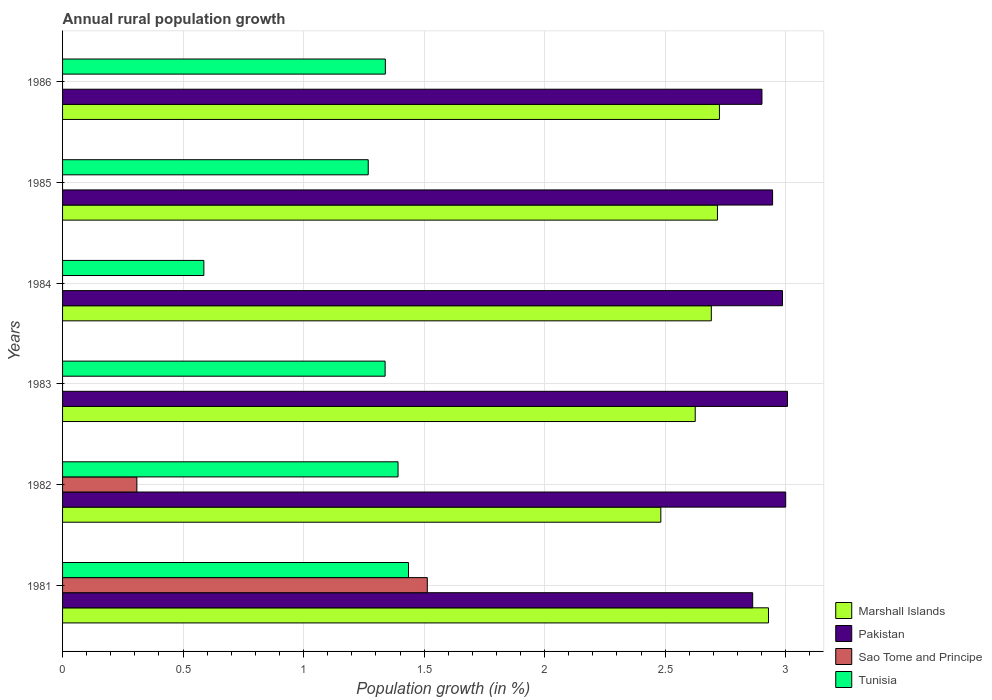Are the number of bars per tick equal to the number of legend labels?
Offer a terse response. No. How many bars are there on the 1st tick from the top?
Make the answer very short. 3. In how many cases, is the number of bars for a given year not equal to the number of legend labels?
Your response must be concise. 4. What is the percentage of rural population growth in Tunisia in 1983?
Keep it short and to the point. 1.34. Across all years, what is the maximum percentage of rural population growth in Pakistan?
Your answer should be very brief. 3.01. Across all years, what is the minimum percentage of rural population growth in Marshall Islands?
Ensure brevity in your answer.  2.48. In which year was the percentage of rural population growth in Tunisia maximum?
Offer a terse response. 1981. What is the total percentage of rural population growth in Marshall Islands in the graph?
Provide a short and direct response. 16.17. What is the difference between the percentage of rural population growth in Pakistan in 1983 and that in 1985?
Your answer should be compact. 0.06. What is the difference between the percentage of rural population growth in Tunisia in 1985 and the percentage of rural population growth in Marshall Islands in 1983?
Make the answer very short. -1.36. What is the average percentage of rural population growth in Pakistan per year?
Your response must be concise. 2.95. In the year 1985, what is the difference between the percentage of rural population growth in Pakistan and percentage of rural population growth in Tunisia?
Give a very brief answer. 1.68. What is the ratio of the percentage of rural population growth in Tunisia in 1981 to that in 1985?
Offer a terse response. 1.13. Is the percentage of rural population growth in Marshall Islands in 1981 less than that in 1985?
Offer a terse response. No. Is the difference between the percentage of rural population growth in Pakistan in 1982 and 1983 greater than the difference between the percentage of rural population growth in Tunisia in 1982 and 1983?
Give a very brief answer. No. What is the difference between the highest and the second highest percentage of rural population growth in Pakistan?
Offer a very short reply. 0.01. What is the difference between the highest and the lowest percentage of rural population growth in Marshall Islands?
Make the answer very short. 0.45. Is it the case that in every year, the sum of the percentage of rural population growth in Marshall Islands and percentage of rural population growth in Sao Tome and Principe is greater than the sum of percentage of rural population growth in Pakistan and percentage of rural population growth in Tunisia?
Make the answer very short. No. How many years are there in the graph?
Make the answer very short. 6. What is the difference between two consecutive major ticks on the X-axis?
Offer a terse response. 0.5. Are the values on the major ticks of X-axis written in scientific E-notation?
Your answer should be very brief. No. Does the graph contain grids?
Your response must be concise. Yes. Where does the legend appear in the graph?
Provide a succinct answer. Bottom right. What is the title of the graph?
Make the answer very short. Annual rural population growth. Does "Liechtenstein" appear as one of the legend labels in the graph?
Provide a succinct answer. No. What is the label or title of the X-axis?
Your answer should be very brief. Population growth (in %). What is the Population growth (in %) in Marshall Islands in 1981?
Keep it short and to the point. 2.93. What is the Population growth (in %) of Pakistan in 1981?
Your answer should be very brief. 2.86. What is the Population growth (in %) of Sao Tome and Principe in 1981?
Offer a terse response. 1.51. What is the Population growth (in %) in Tunisia in 1981?
Make the answer very short. 1.44. What is the Population growth (in %) in Marshall Islands in 1982?
Offer a terse response. 2.48. What is the Population growth (in %) of Pakistan in 1982?
Give a very brief answer. 3. What is the Population growth (in %) in Sao Tome and Principe in 1982?
Your response must be concise. 0.31. What is the Population growth (in %) in Tunisia in 1982?
Offer a terse response. 1.39. What is the Population growth (in %) of Marshall Islands in 1983?
Offer a very short reply. 2.62. What is the Population growth (in %) of Pakistan in 1983?
Provide a succinct answer. 3.01. What is the Population growth (in %) in Sao Tome and Principe in 1983?
Provide a succinct answer. 0. What is the Population growth (in %) in Tunisia in 1983?
Keep it short and to the point. 1.34. What is the Population growth (in %) in Marshall Islands in 1984?
Offer a very short reply. 2.69. What is the Population growth (in %) in Pakistan in 1984?
Ensure brevity in your answer.  2.99. What is the Population growth (in %) of Tunisia in 1984?
Make the answer very short. 0.59. What is the Population growth (in %) of Marshall Islands in 1985?
Your answer should be compact. 2.72. What is the Population growth (in %) of Pakistan in 1985?
Make the answer very short. 2.95. What is the Population growth (in %) in Tunisia in 1985?
Make the answer very short. 1.27. What is the Population growth (in %) in Marshall Islands in 1986?
Ensure brevity in your answer.  2.73. What is the Population growth (in %) of Pakistan in 1986?
Provide a short and direct response. 2.9. What is the Population growth (in %) in Tunisia in 1986?
Your answer should be compact. 1.34. Across all years, what is the maximum Population growth (in %) of Marshall Islands?
Ensure brevity in your answer.  2.93. Across all years, what is the maximum Population growth (in %) of Pakistan?
Make the answer very short. 3.01. Across all years, what is the maximum Population growth (in %) of Sao Tome and Principe?
Make the answer very short. 1.51. Across all years, what is the maximum Population growth (in %) in Tunisia?
Provide a succinct answer. 1.44. Across all years, what is the minimum Population growth (in %) in Marshall Islands?
Your response must be concise. 2.48. Across all years, what is the minimum Population growth (in %) in Pakistan?
Offer a very short reply. 2.86. Across all years, what is the minimum Population growth (in %) of Tunisia?
Give a very brief answer. 0.59. What is the total Population growth (in %) in Marshall Islands in the graph?
Your answer should be compact. 16.17. What is the total Population growth (in %) of Pakistan in the graph?
Your answer should be very brief. 17.7. What is the total Population growth (in %) of Sao Tome and Principe in the graph?
Offer a terse response. 1.82. What is the total Population growth (in %) in Tunisia in the graph?
Provide a succinct answer. 7.36. What is the difference between the Population growth (in %) of Marshall Islands in 1981 and that in 1982?
Your answer should be very brief. 0.45. What is the difference between the Population growth (in %) in Pakistan in 1981 and that in 1982?
Provide a short and direct response. -0.14. What is the difference between the Population growth (in %) of Sao Tome and Principe in 1981 and that in 1982?
Make the answer very short. 1.2. What is the difference between the Population growth (in %) of Tunisia in 1981 and that in 1982?
Give a very brief answer. 0.04. What is the difference between the Population growth (in %) of Marshall Islands in 1981 and that in 1983?
Ensure brevity in your answer.  0.3. What is the difference between the Population growth (in %) of Pakistan in 1981 and that in 1983?
Your answer should be very brief. -0.14. What is the difference between the Population growth (in %) in Tunisia in 1981 and that in 1983?
Your response must be concise. 0.1. What is the difference between the Population growth (in %) of Marshall Islands in 1981 and that in 1984?
Ensure brevity in your answer.  0.24. What is the difference between the Population growth (in %) in Pakistan in 1981 and that in 1984?
Ensure brevity in your answer.  -0.12. What is the difference between the Population growth (in %) in Tunisia in 1981 and that in 1984?
Offer a terse response. 0.85. What is the difference between the Population growth (in %) of Marshall Islands in 1981 and that in 1985?
Ensure brevity in your answer.  0.21. What is the difference between the Population growth (in %) in Pakistan in 1981 and that in 1985?
Your response must be concise. -0.08. What is the difference between the Population growth (in %) in Tunisia in 1981 and that in 1985?
Provide a short and direct response. 0.17. What is the difference between the Population growth (in %) in Marshall Islands in 1981 and that in 1986?
Provide a succinct answer. 0.2. What is the difference between the Population growth (in %) in Pakistan in 1981 and that in 1986?
Offer a very short reply. -0.04. What is the difference between the Population growth (in %) in Tunisia in 1981 and that in 1986?
Ensure brevity in your answer.  0.1. What is the difference between the Population growth (in %) of Marshall Islands in 1982 and that in 1983?
Keep it short and to the point. -0.14. What is the difference between the Population growth (in %) in Pakistan in 1982 and that in 1983?
Provide a succinct answer. -0.01. What is the difference between the Population growth (in %) in Tunisia in 1982 and that in 1983?
Your answer should be compact. 0.05. What is the difference between the Population growth (in %) in Marshall Islands in 1982 and that in 1984?
Provide a succinct answer. -0.21. What is the difference between the Population growth (in %) of Pakistan in 1982 and that in 1984?
Provide a succinct answer. 0.01. What is the difference between the Population growth (in %) of Tunisia in 1982 and that in 1984?
Give a very brief answer. 0.81. What is the difference between the Population growth (in %) in Marshall Islands in 1982 and that in 1985?
Provide a succinct answer. -0.23. What is the difference between the Population growth (in %) of Pakistan in 1982 and that in 1985?
Offer a terse response. 0.05. What is the difference between the Population growth (in %) of Tunisia in 1982 and that in 1985?
Provide a succinct answer. 0.12. What is the difference between the Population growth (in %) in Marshall Islands in 1982 and that in 1986?
Offer a very short reply. -0.24. What is the difference between the Population growth (in %) in Pakistan in 1982 and that in 1986?
Your answer should be compact. 0.1. What is the difference between the Population growth (in %) of Tunisia in 1982 and that in 1986?
Your response must be concise. 0.05. What is the difference between the Population growth (in %) of Marshall Islands in 1983 and that in 1984?
Offer a terse response. -0.07. What is the difference between the Population growth (in %) of Pakistan in 1983 and that in 1984?
Give a very brief answer. 0.02. What is the difference between the Population growth (in %) of Tunisia in 1983 and that in 1984?
Your answer should be compact. 0.75. What is the difference between the Population growth (in %) in Marshall Islands in 1983 and that in 1985?
Keep it short and to the point. -0.09. What is the difference between the Population growth (in %) in Pakistan in 1983 and that in 1985?
Give a very brief answer. 0.06. What is the difference between the Population growth (in %) in Tunisia in 1983 and that in 1985?
Offer a very short reply. 0.07. What is the difference between the Population growth (in %) in Marshall Islands in 1983 and that in 1986?
Provide a short and direct response. -0.1. What is the difference between the Population growth (in %) of Pakistan in 1983 and that in 1986?
Your answer should be very brief. 0.11. What is the difference between the Population growth (in %) in Tunisia in 1983 and that in 1986?
Give a very brief answer. -0. What is the difference between the Population growth (in %) of Marshall Islands in 1984 and that in 1985?
Ensure brevity in your answer.  -0.03. What is the difference between the Population growth (in %) of Pakistan in 1984 and that in 1985?
Your answer should be very brief. 0.04. What is the difference between the Population growth (in %) of Tunisia in 1984 and that in 1985?
Ensure brevity in your answer.  -0.68. What is the difference between the Population growth (in %) of Marshall Islands in 1984 and that in 1986?
Ensure brevity in your answer.  -0.03. What is the difference between the Population growth (in %) of Pakistan in 1984 and that in 1986?
Your answer should be very brief. 0.09. What is the difference between the Population growth (in %) of Tunisia in 1984 and that in 1986?
Make the answer very short. -0.75. What is the difference between the Population growth (in %) in Marshall Islands in 1985 and that in 1986?
Your response must be concise. -0.01. What is the difference between the Population growth (in %) of Pakistan in 1985 and that in 1986?
Provide a short and direct response. 0.04. What is the difference between the Population growth (in %) in Tunisia in 1985 and that in 1986?
Your answer should be compact. -0.07. What is the difference between the Population growth (in %) in Marshall Islands in 1981 and the Population growth (in %) in Pakistan in 1982?
Ensure brevity in your answer.  -0.07. What is the difference between the Population growth (in %) of Marshall Islands in 1981 and the Population growth (in %) of Sao Tome and Principe in 1982?
Your response must be concise. 2.62. What is the difference between the Population growth (in %) in Marshall Islands in 1981 and the Population growth (in %) in Tunisia in 1982?
Your answer should be compact. 1.54. What is the difference between the Population growth (in %) in Pakistan in 1981 and the Population growth (in %) in Sao Tome and Principe in 1982?
Provide a short and direct response. 2.55. What is the difference between the Population growth (in %) of Pakistan in 1981 and the Population growth (in %) of Tunisia in 1982?
Your response must be concise. 1.47. What is the difference between the Population growth (in %) of Sao Tome and Principe in 1981 and the Population growth (in %) of Tunisia in 1982?
Keep it short and to the point. 0.12. What is the difference between the Population growth (in %) of Marshall Islands in 1981 and the Population growth (in %) of Pakistan in 1983?
Your answer should be very brief. -0.08. What is the difference between the Population growth (in %) in Marshall Islands in 1981 and the Population growth (in %) in Tunisia in 1983?
Provide a succinct answer. 1.59. What is the difference between the Population growth (in %) in Pakistan in 1981 and the Population growth (in %) in Tunisia in 1983?
Ensure brevity in your answer.  1.52. What is the difference between the Population growth (in %) of Sao Tome and Principe in 1981 and the Population growth (in %) of Tunisia in 1983?
Provide a short and direct response. 0.18. What is the difference between the Population growth (in %) in Marshall Islands in 1981 and the Population growth (in %) in Pakistan in 1984?
Provide a short and direct response. -0.06. What is the difference between the Population growth (in %) of Marshall Islands in 1981 and the Population growth (in %) of Tunisia in 1984?
Ensure brevity in your answer.  2.34. What is the difference between the Population growth (in %) in Pakistan in 1981 and the Population growth (in %) in Tunisia in 1984?
Offer a terse response. 2.28. What is the difference between the Population growth (in %) of Sao Tome and Principe in 1981 and the Population growth (in %) of Tunisia in 1984?
Offer a terse response. 0.93. What is the difference between the Population growth (in %) of Marshall Islands in 1981 and the Population growth (in %) of Pakistan in 1985?
Make the answer very short. -0.02. What is the difference between the Population growth (in %) of Marshall Islands in 1981 and the Population growth (in %) of Tunisia in 1985?
Offer a terse response. 1.66. What is the difference between the Population growth (in %) of Pakistan in 1981 and the Population growth (in %) of Tunisia in 1985?
Keep it short and to the point. 1.59. What is the difference between the Population growth (in %) of Sao Tome and Principe in 1981 and the Population growth (in %) of Tunisia in 1985?
Your answer should be very brief. 0.25. What is the difference between the Population growth (in %) of Marshall Islands in 1981 and the Population growth (in %) of Pakistan in 1986?
Offer a very short reply. 0.03. What is the difference between the Population growth (in %) of Marshall Islands in 1981 and the Population growth (in %) of Tunisia in 1986?
Your answer should be very brief. 1.59. What is the difference between the Population growth (in %) in Pakistan in 1981 and the Population growth (in %) in Tunisia in 1986?
Offer a terse response. 1.52. What is the difference between the Population growth (in %) in Sao Tome and Principe in 1981 and the Population growth (in %) in Tunisia in 1986?
Ensure brevity in your answer.  0.17. What is the difference between the Population growth (in %) in Marshall Islands in 1982 and the Population growth (in %) in Pakistan in 1983?
Offer a very short reply. -0.53. What is the difference between the Population growth (in %) of Marshall Islands in 1982 and the Population growth (in %) of Tunisia in 1983?
Ensure brevity in your answer.  1.14. What is the difference between the Population growth (in %) in Pakistan in 1982 and the Population growth (in %) in Tunisia in 1983?
Provide a succinct answer. 1.66. What is the difference between the Population growth (in %) in Sao Tome and Principe in 1982 and the Population growth (in %) in Tunisia in 1983?
Ensure brevity in your answer.  -1.03. What is the difference between the Population growth (in %) of Marshall Islands in 1982 and the Population growth (in %) of Pakistan in 1984?
Make the answer very short. -0.5. What is the difference between the Population growth (in %) of Marshall Islands in 1982 and the Population growth (in %) of Tunisia in 1984?
Make the answer very short. 1.9. What is the difference between the Population growth (in %) in Pakistan in 1982 and the Population growth (in %) in Tunisia in 1984?
Offer a very short reply. 2.41. What is the difference between the Population growth (in %) of Sao Tome and Principe in 1982 and the Population growth (in %) of Tunisia in 1984?
Provide a succinct answer. -0.28. What is the difference between the Population growth (in %) of Marshall Islands in 1982 and the Population growth (in %) of Pakistan in 1985?
Ensure brevity in your answer.  -0.46. What is the difference between the Population growth (in %) in Marshall Islands in 1982 and the Population growth (in %) in Tunisia in 1985?
Your answer should be compact. 1.21. What is the difference between the Population growth (in %) of Pakistan in 1982 and the Population growth (in %) of Tunisia in 1985?
Provide a succinct answer. 1.73. What is the difference between the Population growth (in %) in Sao Tome and Principe in 1982 and the Population growth (in %) in Tunisia in 1985?
Offer a terse response. -0.96. What is the difference between the Population growth (in %) in Marshall Islands in 1982 and the Population growth (in %) in Pakistan in 1986?
Provide a short and direct response. -0.42. What is the difference between the Population growth (in %) in Marshall Islands in 1982 and the Population growth (in %) in Tunisia in 1986?
Make the answer very short. 1.14. What is the difference between the Population growth (in %) of Pakistan in 1982 and the Population growth (in %) of Tunisia in 1986?
Ensure brevity in your answer.  1.66. What is the difference between the Population growth (in %) in Sao Tome and Principe in 1982 and the Population growth (in %) in Tunisia in 1986?
Provide a short and direct response. -1.03. What is the difference between the Population growth (in %) in Marshall Islands in 1983 and the Population growth (in %) in Pakistan in 1984?
Your answer should be very brief. -0.36. What is the difference between the Population growth (in %) in Marshall Islands in 1983 and the Population growth (in %) in Tunisia in 1984?
Your answer should be very brief. 2.04. What is the difference between the Population growth (in %) of Pakistan in 1983 and the Population growth (in %) of Tunisia in 1984?
Your answer should be compact. 2.42. What is the difference between the Population growth (in %) of Marshall Islands in 1983 and the Population growth (in %) of Pakistan in 1985?
Give a very brief answer. -0.32. What is the difference between the Population growth (in %) in Marshall Islands in 1983 and the Population growth (in %) in Tunisia in 1985?
Give a very brief answer. 1.36. What is the difference between the Population growth (in %) of Pakistan in 1983 and the Population growth (in %) of Tunisia in 1985?
Make the answer very short. 1.74. What is the difference between the Population growth (in %) in Marshall Islands in 1983 and the Population growth (in %) in Pakistan in 1986?
Your answer should be very brief. -0.28. What is the difference between the Population growth (in %) in Marshall Islands in 1983 and the Population growth (in %) in Tunisia in 1986?
Offer a terse response. 1.29. What is the difference between the Population growth (in %) of Pakistan in 1983 and the Population growth (in %) of Tunisia in 1986?
Your answer should be very brief. 1.67. What is the difference between the Population growth (in %) in Marshall Islands in 1984 and the Population growth (in %) in Pakistan in 1985?
Provide a short and direct response. -0.25. What is the difference between the Population growth (in %) in Marshall Islands in 1984 and the Population growth (in %) in Tunisia in 1985?
Provide a short and direct response. 1.42. What is the difference between the Population growth (in %) in Pakistan in 1984 and the Population growth (in %) in Tunisia in 1985?
Keep it short and to the point. 1.72. What is the difference between the Population growth (in %) of Marshall Islands in 1984 and the Population growth (in %) of Pakistan in 1986?
Your response must be concise. -0.21. What is the difference between the Population growth (in %) of Marshall Islands in 1984 and the Population growth (in %) of Tunisia in 1986?
Offer a very short reply. 1.35. What is the difference between the Population growth (in %) of Pakistan in 1984 and the Population growth (in %) of Tunisia in 1986?
Provide a succinct answer. 1.65. What is the difference between the Population growth (in %) in Marshall Islands in 1985 and the Population growth (in %) in Pakistan in 1986?
Offer a very short reply. -0.18. What is the difference between the Population growth (in %) in Marshall Islands in 1985 and the Population growth (in %) in Tunisia in 1986?
Provide a succinct answer. 1.38. What is the difference between the Population growth (in %) in Pakistan in 1985 and the Population growth (in %) in Tunisia in 1986?
Make the answer very short. 1.61. What is the average Population growth (in %) of Marshall Islands per year?
Give a very brief answer. 2.69. What is the average Population growth (in %) in Pakistan per year?
Your response must be concise. 2.95. What is the average Population growth (in %) of Sao Tome and Principe per year?
Offer a very short reply. 0.3. What is the average Population growth (in %) of Tunisia per year?
Offer a terse response. 1.23. In the year 1981, what is the difference between the Population growth (in %) in Marshall Islands and Population growth (in %) in Pakistan?
Ensure brevity in your answer.  0.07. In the year 1981, what is the difference between the Population growth (in %) of Marshall Islands and Population growth (in %) of Sao Tome and Principe?
Make the answer very short. 1.42. In the year 1981, what is the difference between the Population growth (in %) of Marshall Islands and Population growth (in %) of Tunisia?
Offer a very short reply. 1.49. In the year 1981, what is the difference between the Population growth (in %) in Pakistan and Population growth (in %) in Sao Tome and Principe?
Give a very brief answer. 1.35. In the year 1981, what is the difference between the Population growth (in %) in Pakistan and Population growth (in %) in Tunisia?
Offer a terse response. 1.43. In the year 1981, what is the difference between the Population growth (in %) of Sao Tome and Principe and Population growth (in %) of Tunisia?
Provide a short and direct response. 0.08. In the year 1982, what is the difference between the Population growth (in %) in Marshall Islands and Population growth (in %) in Pakistan?
Provide a short and direct response. -0.52. In the year 1982, what is the difference between the Population growth (in %) in Marshall Islands and Population growth (in %) in Sao Tome and Principe?
Offer a very short reply. 2.17. In the year 1982, what is the difference between the Population growth (in %) of Marshall Islands and Population growth (in %) of Tunisia?
Provide a succinct answer. 1.09. In the year 1982, what is the difference between the Population growth (in %) in Pakistan and Population growth (in %) in Sao Tome and Principe?
Provide a succinct answer. 2.69. In the year 1982, what is the difference between the Population growth (in %) of Pakistan and Population growth (in %) of Tunisia?
Your answer should be very brief. 1.61. In the year 1982, what is the difference between the Population growth (in %) of Sao Tome and Principe and Population growth (in %) of Tunisia?
Offer a terse response. -1.08. In the year 1983, what is the difference between the Population growth (in %) of Marshall Islands and Population growth (in %) of Pakistan?
Provide a short and direct response. -0.38. In the year 1983, what is the difference between the Population growth (in %) in Marshall Islands and Population growth (in %) in Tunisia?
Provide a succinct answer. 1.29. In the year 1983, what is the difference between the Population growth (in %) of Pakistan and Population growth (in %) of Tunisia?
Keep it short and to the point. 1.67. In the year 1984, what is the difference between the Population growth (in %) in Marshall Islands and Population growth (in %) in Pakistan?
Your answer should be compact. -0.3. In the year 1984, what is the difference between the Population growth (in %) in Marshall Islands and Population growth (in %) in Tunisia?
Ensure brevity in your answer.  2.11. In the year 1984, what is the difference between the Population growth (in %) of Pakistan and Population growth (in %) of Tunisia?
Give a very brief answer. 2.4. In the year 1985, what is the difference between the Population growth (in %) of Marshall Islands and Population growth (in %) of Pakistan?
Ensure brevity in your answer.  -0.23. In the year 1985, what is the difference between the Population growth (in %) of Marshall Islands and Population growth (in %) of Tunisia?
Your response must be concise. 1.45. In the year 1985, what is the difference between the Population growth (in %) of Pakistan and Population growth (in %) of Tunisia?
Ensure brevity in your answer.  1.68. In the year 1986, what is the difference between the Population growth (in %) in Marshall Islands and Population growth (in %) in Pakistan?
Your response must be concise. -0.18. In the year 1986, what is the difference between the Population growth (in %) of Marshall Islands and Population growth (in %) of Tunisia?
Give a very brief answer. 1.39. In the year 1986, what is the difference between the Population growth (in %) in Pakistan and Population growth (in %) in Tunisia?
Your response must be concise. 1.56. What is the ratio of the Population growth (in %) in Marshall Islands in 1981 to that in 1982?
Give a very brief answer. 1.18. What is the ratio of the Population growth (in %) of Pakistan in 1981 to that in 1982?
Provide a succinct answer. 0.95. What is the ratio of the Population growth (in %) in Sao Tome and Principe in 1981 to that in 1982?
Provide a succinct answer. 4.91. What is the ratio of the Population growth (in %) of Tunisia in 1981 to that in 1982?
Keep it short and to the point. 1.03. What is the ratio of the Population growth (in %) in Marshall Islands in 1981 to that in 1983?
Give a very brief answer. 1.12. What is the ratio of the Population growth (in %) in Pakistan in 1981 to that in 1983?
Ensure brevity in your answer.  0.95. What is the ratio of the Population growth (in %) of Tunisia in 1981 to that in 1983?
Your answer should be very brief. 1.07. What is the ratio of the Population growth (in %) in Marshall Islands in 1981 to that in 1984?
Your answer should be compact. 1.09. What is the ratio of the Population growth (in %) in Pakistan in 1981 to that in 1984?
Give a very brief answer. 0.96. What is the ratio of the Population growth (in %) in Tunisia in 1981 to that in 1984?
Provide a short and direct response. 2.45. What is the ratio of the Population growth (in %) in Marshall Islands in 1981 to that in 1985?
Give a very brief answer. 1.08. What is the ratio of the Population growth (in %) in Pakistan in 1981 to that in 1985?
Your answer should be compact. 0.97. What is the ratio of the Population growth (in %) of Tunisia in 1981 to that in 1985?
Your answer should be compact. 1.13. What is the ratio of the Population growth (in %) in Marshall Islands in 1981 to that in 1986?
Give a very brief answer. 1.07. What is the ratio of the Population growth (in %) of Pakistan in 1981 to that in 1986?
Offer a terse response. 0.99. What is the ratio of the Population growth (in %) in Tunisia in 1981 to that in 1986?
Ensure brevity in your answer.  1.07. What is the ratio of the Population growth (in %) of Marshall Islands in 1982 to that in 1983?
Keep it short and to the point. 0.95. What is the ratio of the Population growth (in %) in Tunisia in 1982 to that in 1983?
Your response must be concise. 1.04. What is the ratio of the Population growth (in %) in Marshall Islands in 1982 to that in 1984?
Ensure brevity in your answer.  0.92. What is the ratio of the Population growth (in %) in Tunisia in 1982 to that in 1984?
Provide a succinct answer. 2.37. What is the ratio of the Population growth (in %) in Marshall Islands in 1982 to that in 1985?
Offer a terse response. 0.91. What is the ratio of the Population growth (in %) in Pakistan in 1982 to that in 1985?
Your answer should be compact. 1.02. What is the ratio of the Population growth (in %) of Tunisia in 1982 to that in 1985?
Keep it short and to the point. 1.1. What is the ratio of the Population growth (in %) of Marshall Islands in 1982 to that in 1986?
Provide a short and direct response. 0.91. What is the ratio of the Population growth (in %) in Pakistan in 1982 to that in 1986?
Your answer should be compact. 1.03. What is the ratio of the Population growth (in %) in Tunisia in 1982 to that in 1986?
Offer a very short reply. 1.04. What is the ratio of the Population growth (in %) of Marshall Islands in 1983 to that in 1984?
Make the answer very short. 0.98. What is the ratio of the Population growth (in %) of Tunisia in 1983 to that in 1984?
Provide a short and direct response. 2.28. What is the ratio of the Population growth (in %) of Tunisia in 1983 to that in 1985?
Your response must be concise. 1.06. What is the ratio of the Population growth (in %) of Marshall Islands in 1983 to that in 1986?
Offer a terse response. 0.96. What is the ratio of the Population growth (in %) of Pakistan in 1983 to that in 1986?
Keep it short and to the point. 1.04. What is the ratio of the Population growth (in %) of Tunisia in 1983 to that in 1986?
Offer a terse response. 1. What is the ratio of the Population growth (in %) in Marshall Islands in 1984 to that in 1985?
Your answer should be very brief. 0.99. What is the ratio of the Population growth (in %) of Pakistan in 1984 to that in 1985?
Your response must be concise. 1.01. What is the ratio of the Population growth (in %) in Tunisia in 1984 to that in 1985?
Offer a terse response. 0.46. What is the ratio of the Population growth (in %) in Marshall Islands in 1984 to that in 1986?
Your answer should be very brief. 0.99. What is the ratio of the Population growth (in %) of Pakistan in 1984 to that in 1986?
Your answer should be very brief. 1.03. What is the ratio of the Population growth (in %) of Tunisia in 1984 to that in 1986?
Offer a terse response. 0.44. What is the ratio of the Population growth (in %) of Marshall Islands in 1985 to that in 1986?
Provide a short and direct response. 1. What is the ratio of the Population growth (in %) in Pakistan in 1985 to that in 1986?
Your answer should be compact. 1.02. What is the ratio of the Population growth (in %) in Tunisia in 1985 to that in 1986?
Give a very brief answer. 0.95. What is the difference between the highest and the second highest Population growth (in %) in Marshall Islands?
Provide a short and direct response. 0.2. What is the difference between the highest and the second highest Population growth (in %) of Pakistan?
Provide a succinct answer. 0.01. What is the difference between the highest and the second highest Population growth (in %) in Tunisia?
Provide a short and direct response. 0.04. What is the difference between the highest and the lowest Population growth (in %) of Marshall Islands?
Offer a terse response. 0.45. What is the difference between the highest and the lowest Population growth (in %) in Pakistan?
Make the answer very short. 0.14. What is the difference between the highest and the lowest Population growth (in %) in Sao Tome and Principe?
Keep it short and to the point. 1.51. What is the difference between the highest and the lowest Population growth (in %) of Tunisia?
Give a very brief answer. 0.85. 